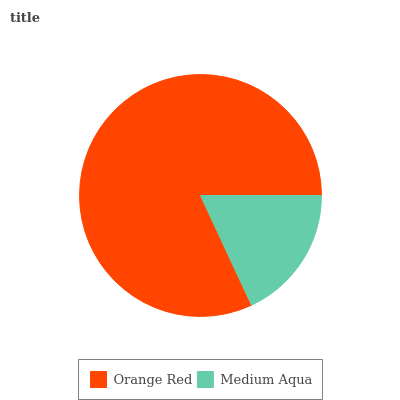Is Medium Aqua the minimum?
Answer yes or no. Yes. Is Orange Red the maximum?
Answer yes or no. Yes. Is Medium Aqua the maximum?
Answer yes or no. No. Is Orange Red greater than Medium Aqua?
Answer yes or no. Yes. Is Medium Aqua less than Orange Red?
Answer yes or no. Yes. Is Medium Aqua greater than Orange Red?
Answer yes or no. No. Is Orange Red less than Medium Aqua?
Answer yes or no. No. Is Orange Red the high median?
Answer yes or no. Yes. Is Medium Aqua the low median?
Answer yes or no. Yes. Is Medium Aqua the high median?
Answer yes or no. No. Is Orange Red the low median?
Answer yes or no. No. 